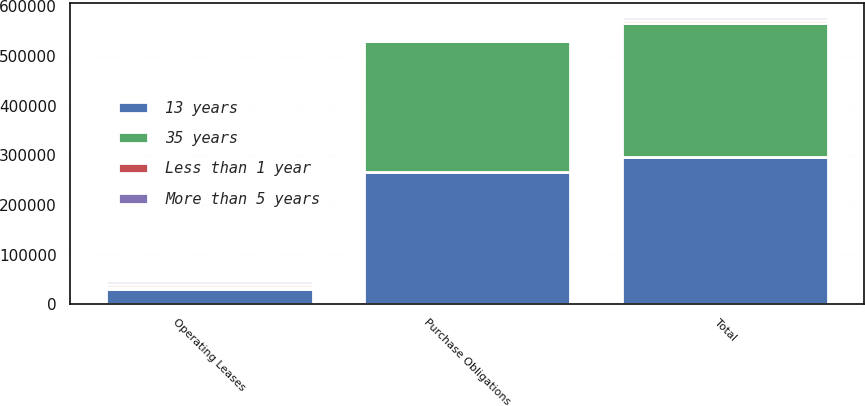Convert chart to OTSL. <chart><loc_0><loc_0><loc_500><loc_500><stacked_bar_chart><ecel><fcel>Operating Leases<fcel>Purchase Obligations<fcel>Total<nl><fcel>13 years<fcel>31145<fcel>265409<fcel>296554<nl><fcel>35 years<fcel>3357<fcel>265409<fcel>268766<nl><fcel>Less than 1 year<fcel>6271<fcel>0<fcel>6271<nl><fcel>More than 5 years<fcel>6040<fcel>0<fcel>6040<nl></chart> 